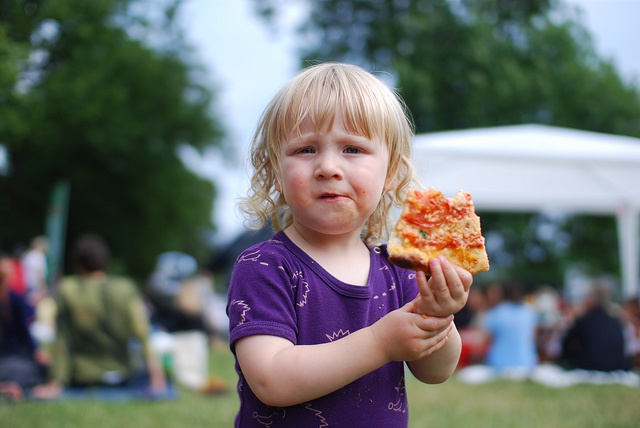Describe the objects in this image and their specific colors. I can see people in black, brown, darkgray, lightgray, and purple tones, people in black, gray, olive, and darkgreen tones, people in black, darkgray, lightgray, and gray tones, people in black, gray, darkgray, and navy tones, and pizza in black, tan, and red tones in this image. 